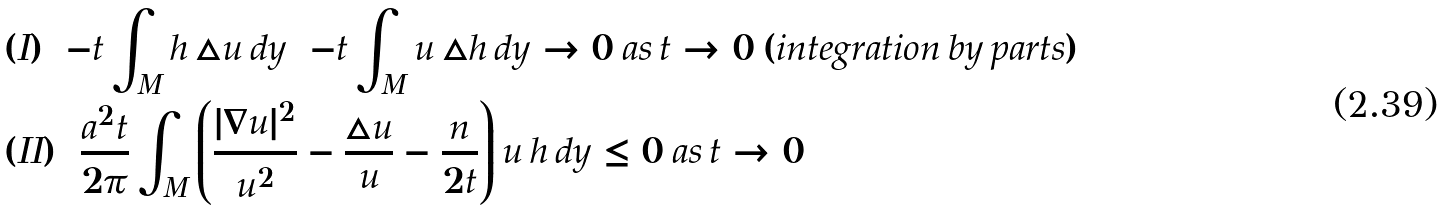<formula> <loc_0><loc_0><loc_500><loc_500>& ( I ) = - t \int _ { M } h \, \triangle u \, d y = - t \int _ { M } u \, \triangle h \, d y \to 0 \, a s \, t \to 0 \, ( i n t e g r a t i o n \, b y \, p a r t s ) \\ & ( I I ) = \frac { a ^ { 2 } t } { 2 \pi } \int _ { M } \left ( \frac { | \nabla u | ^ { 2 } } { u ^ { 2 } } - \frac { \triangle u } { u } - \frac { n } { 2 t } \right ) u \, h \, d y \leq 0 \, a s \, t \to 0</formula> 